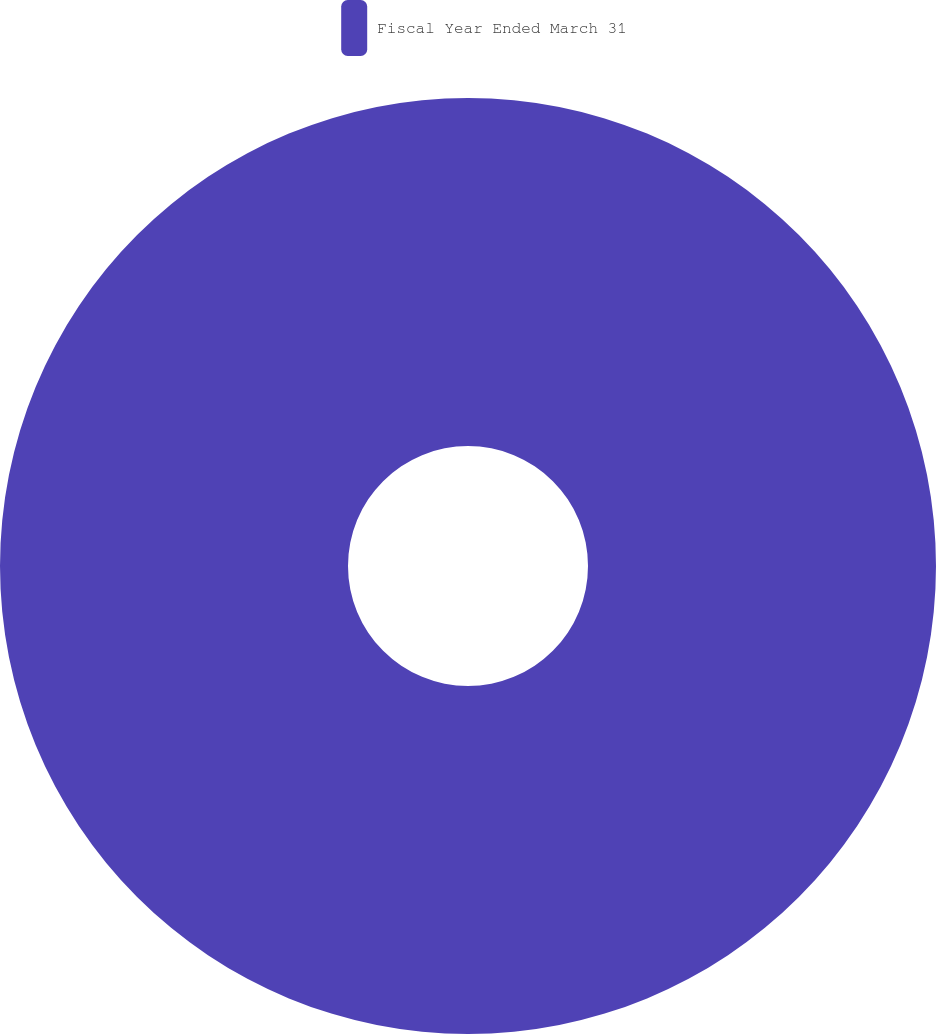Convert chart. <chart><loc_0><loc_0><loc_500><loc_500><pie_chart><fcel>Fiscal Year Ended March 31<nl><fcel>100.0%<nl></chart> 